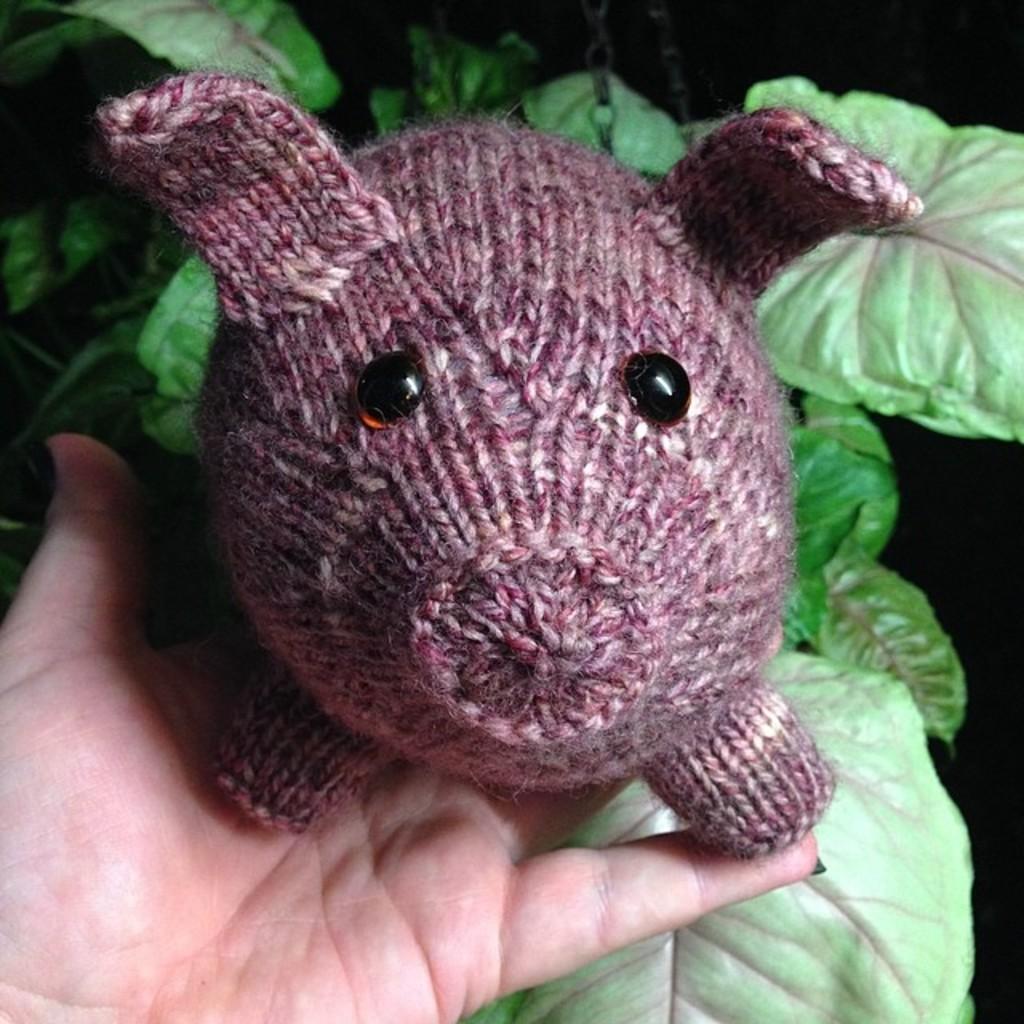Describe this image in one or two sentences. In this image there is a pig doll made with wool in a person's hand, behind the doll there are leaves. 